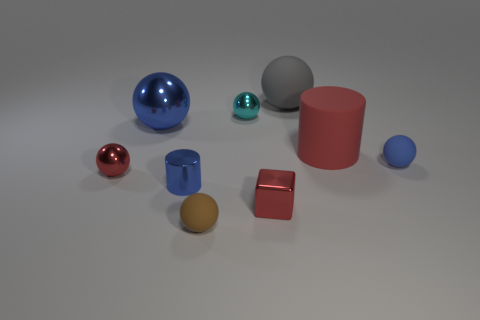How many blue spheres must be subtracted to get 1 blue spheres? 1 Subtract all tiny red spheres. How many spheres are left? 5 Subtract all purple cubes. How many blue balls are left? 2 Subtract all blue balls. How many balls are left? 4 Subtract 2 spheres. How many spheres are left? 4 Subtract all balls. How many objects are left? 3 Add 2 red shiny balls. How many red shiny balls exist? 3 Subtract 0 gray blocks. How many objects are left? 9 Subtract all brown balls. Subtract all gray cubes. How many balls are left? 5 Subtract all big rubber objects. Subtract all big green metal things. How many objects are left? 7 